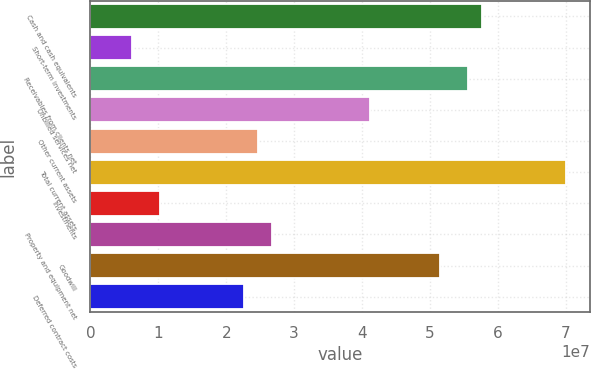<chart> <loc_0><loc_0><loc_500><loc_500><bar_chart><fcel>Cash and cash equivalents<fcel>Short-term investments<fcel>Receivables from clients net<fcel>Unbilled services net<fcel>Other current assets<fcel>Total current assets<fcel>Investments<fcel>Property and equipment net<fcel>Goodwill<fcel>Deferred contract costs<nl><fcel>5.77052e+07<fcel>6.18271e+06<fcel>5.56443e+07<fcel>4.1218e+07<fcel>2.47308e+07<fcel>7.00706e+07<fcel>1.03045e+07<fcel>2.67917e+07<fcel>5.15225e+07<fcel>2.26699e+07<nl></chart> 